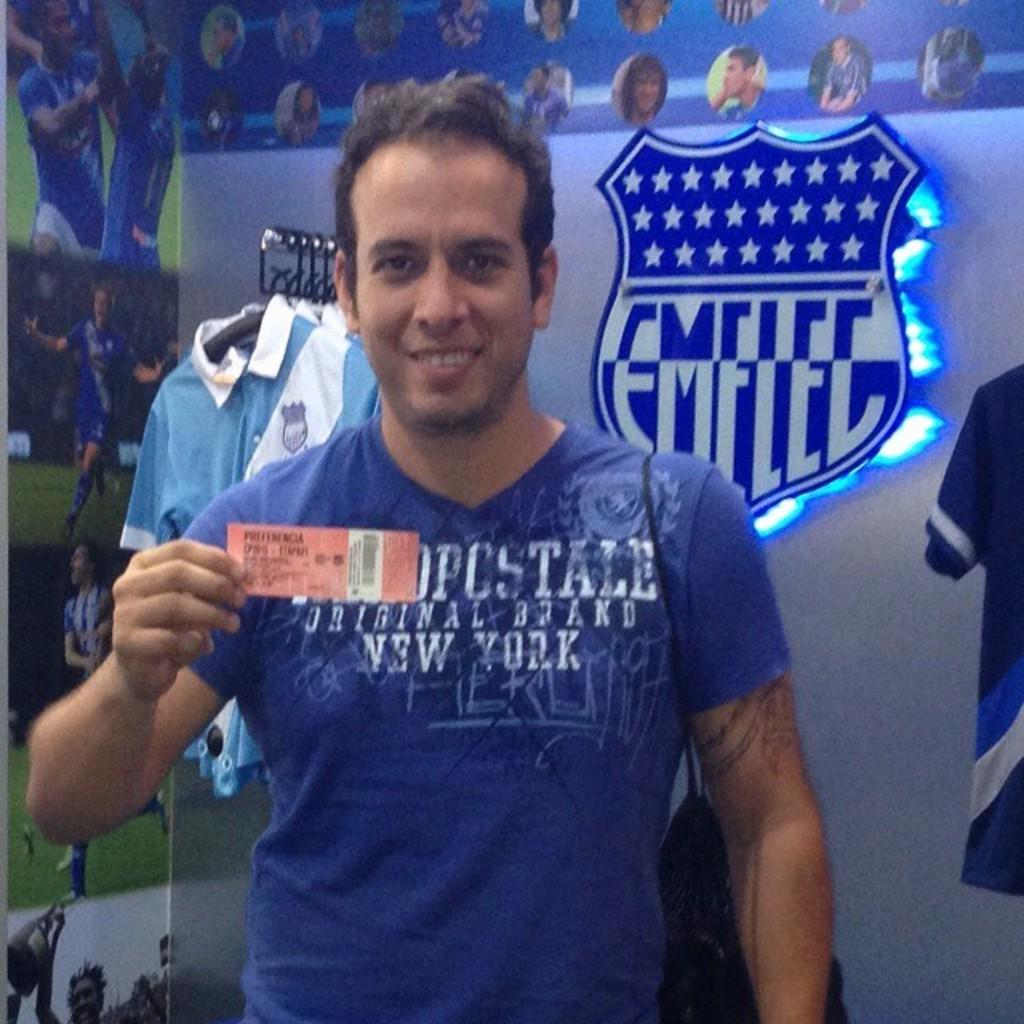<image>
Create a compact narrative representing the image presented. a man with an emelee icon in the background 